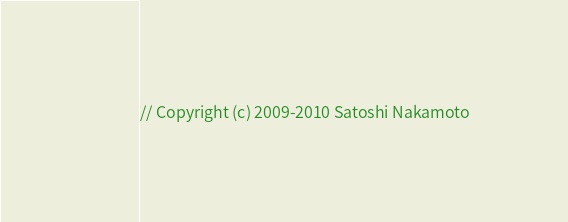<code> <loc_0><loc_0><loc_500><loc_500><_C_>// Copyright (c) 2009-2010 Satoshi Nakamoto</code> 